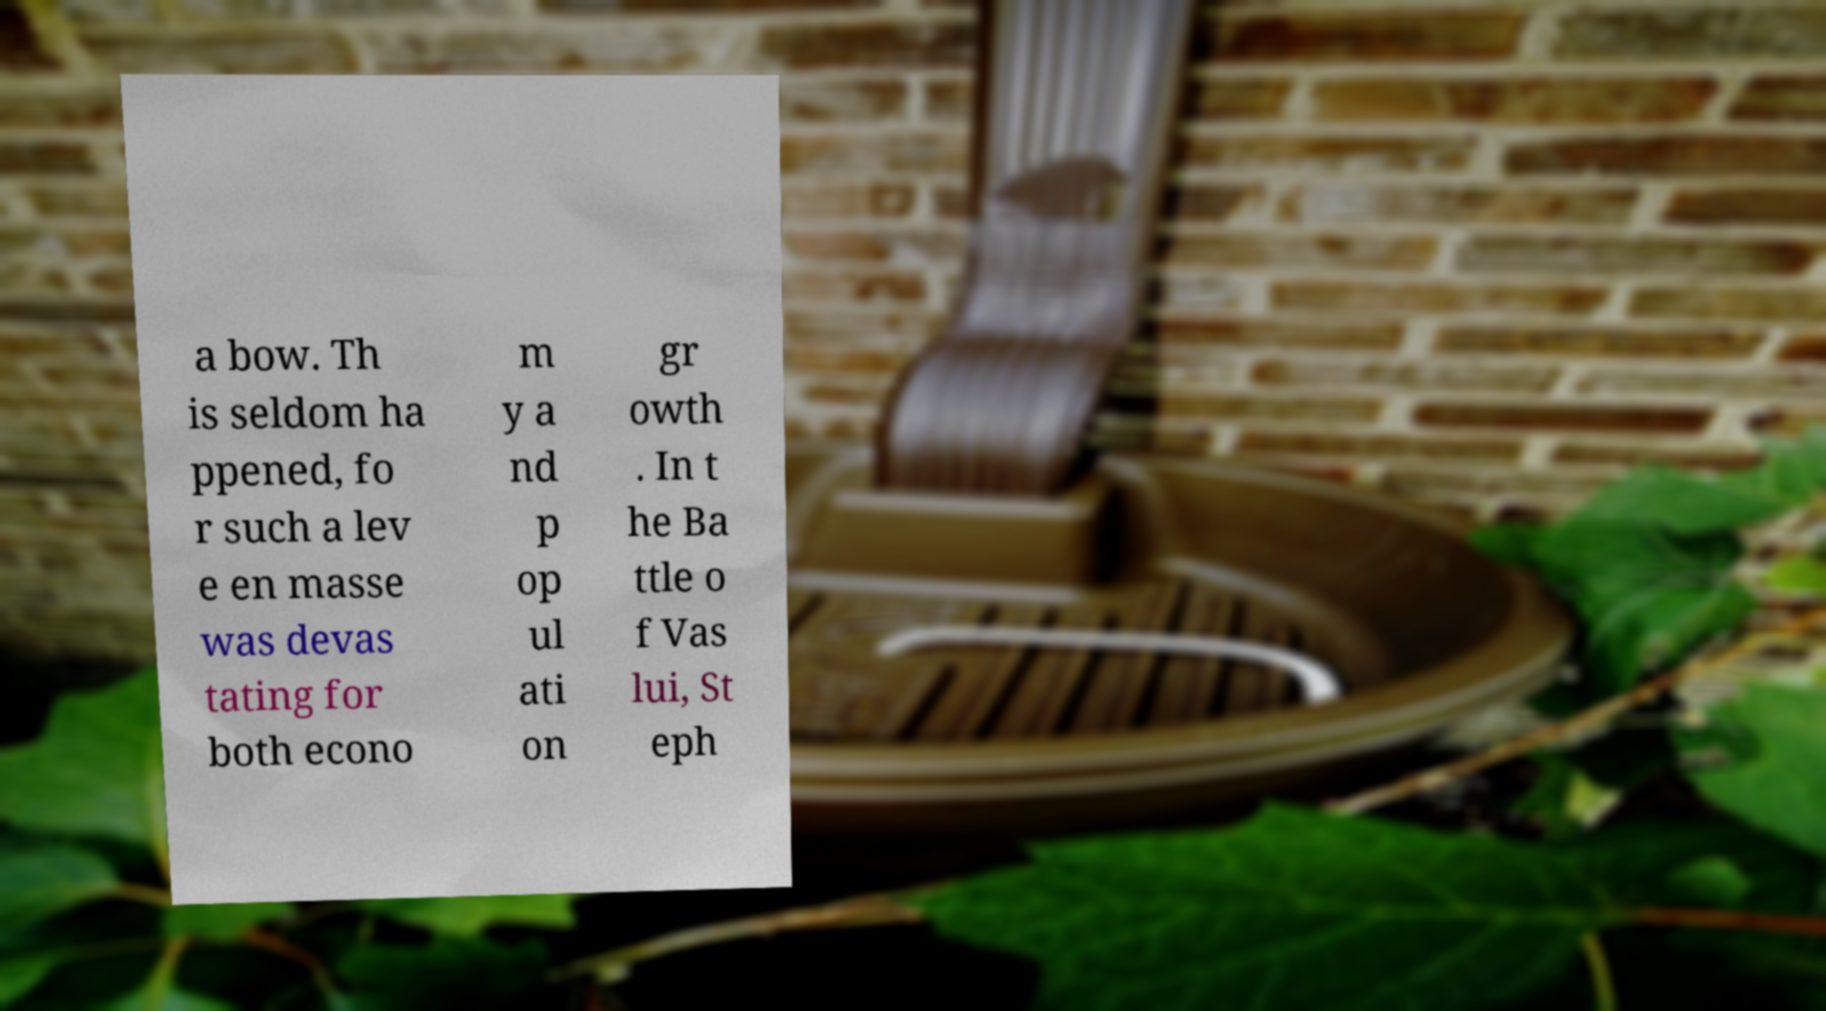Can you accurately transcribe the text from the provided image for me? a bow. Th is seldom ha ppened, fo r such a lev e en masse was devas tating for both econo m y a nd p op ul ati on gr owth . In t he Ba ttle o f Vas lui, St eph 